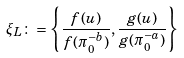<formula> <loc_0><loc_0><loc_500><loc_500>\xi _ { L } \colon = \left \{ \frac { f ( u ) } { f ( \pi _ { 0 } ^ { - b } ) } , \frac { g ( u ) } { g ( \pi _ { 0 } ^ { - a } ) } \right \}</formula> 